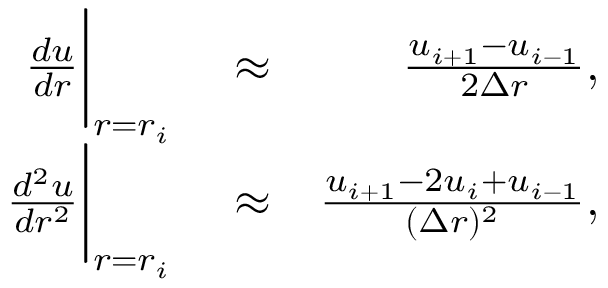<formula> <loc_0><loc_0><loc_500><loc_500>\begin{array} { r l r } { \frac { d u } { d r } \left | _ { r = r _ { i } } } & \approx } & { \frac { u _ { i + 1 } - u _ { i - 1 } } { 2 \Delta r } , } \\ { \frac { d ^ { 2 } u } { d r ^ { 2 } } \right | _ { r = r _ { i } } } & \approx } & { \frac { u _ { i + 1 } - 2 u _ { i } + u _ { i - 1 } } { ( \Delta r ) ^ { 2 } } , } \end{array}</formula> 